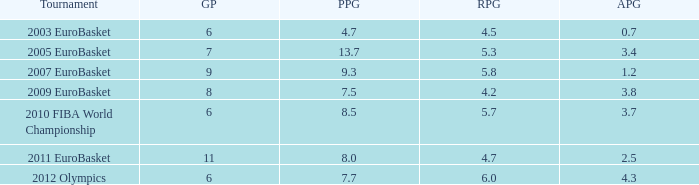Could you help me parse every detail presented in this table? {'header': ['Tournament', 'GP', 'PPG', 'RPG', 'APG'], 'rows': [['2003 EuroBasket', '6', '4.7', '4.5', '0.7'], ['2005 EuroBasket', '7', '13.7', '5.3', '3.4'], ['2007 EuroBasket', '9', '9.3', '5.8', '1.2'], ['2009 EuroBasket', '8', '7.5', '4.2', '3.8'], ['2010 FIBA World Championship', '6', '8.5', '5.7', '3.7'], ['2011 EuroBasket', '11', '8.0', '4.7', '2.5'], ['2012 Olympics', '6', '7.7', '6.0', '4.3']]} How many assists per game have 4.2 rebounds per game? 3.8. 